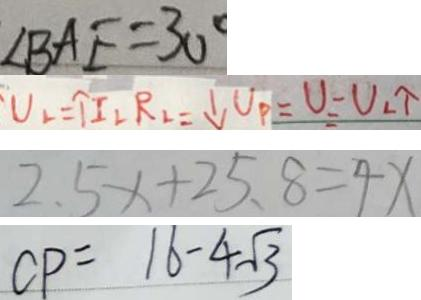<formula> <loc_0><loc_0><loc_500><loc_500>\angle B A E = 3 0 ^ { \circ } 
 U _ { L } = \uparrow I _ { L } R _ { L } = \downarrow U _ { P } = U _ { L } \uparrow 
 2 . 5 x + 2 5 . 8 = 4 x 
 C P = 1 6 - 4 \sqrt { 3 }</formula> 